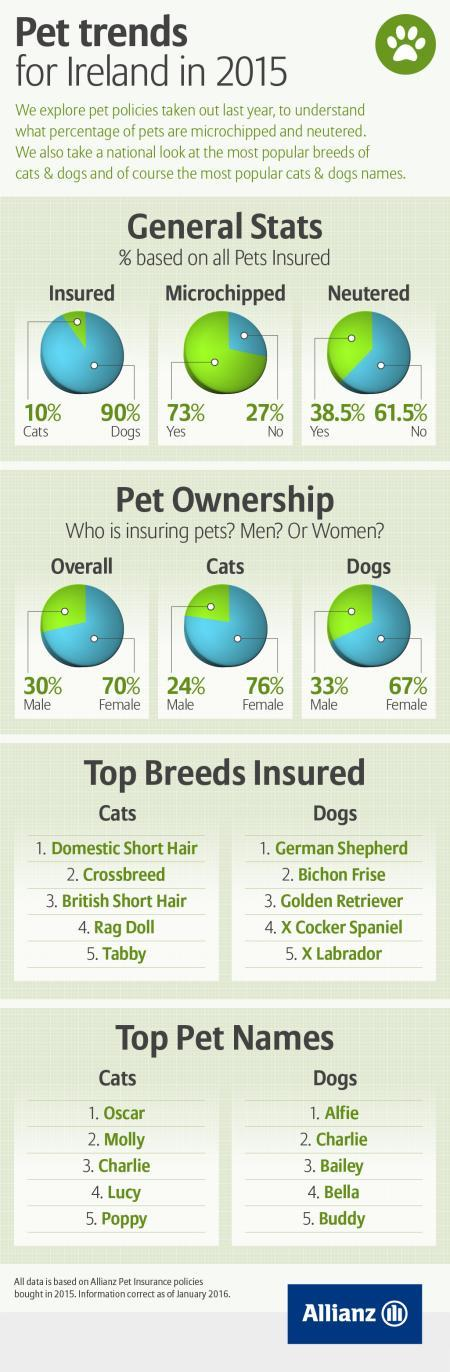Who is insuring cats the most-male or female?
Answer the question with a short phrase. female Who is insuring dogs the most-male or female? female What percentage of pets are microchipped? 73% What percentage of pets are neutered? 38.5% 